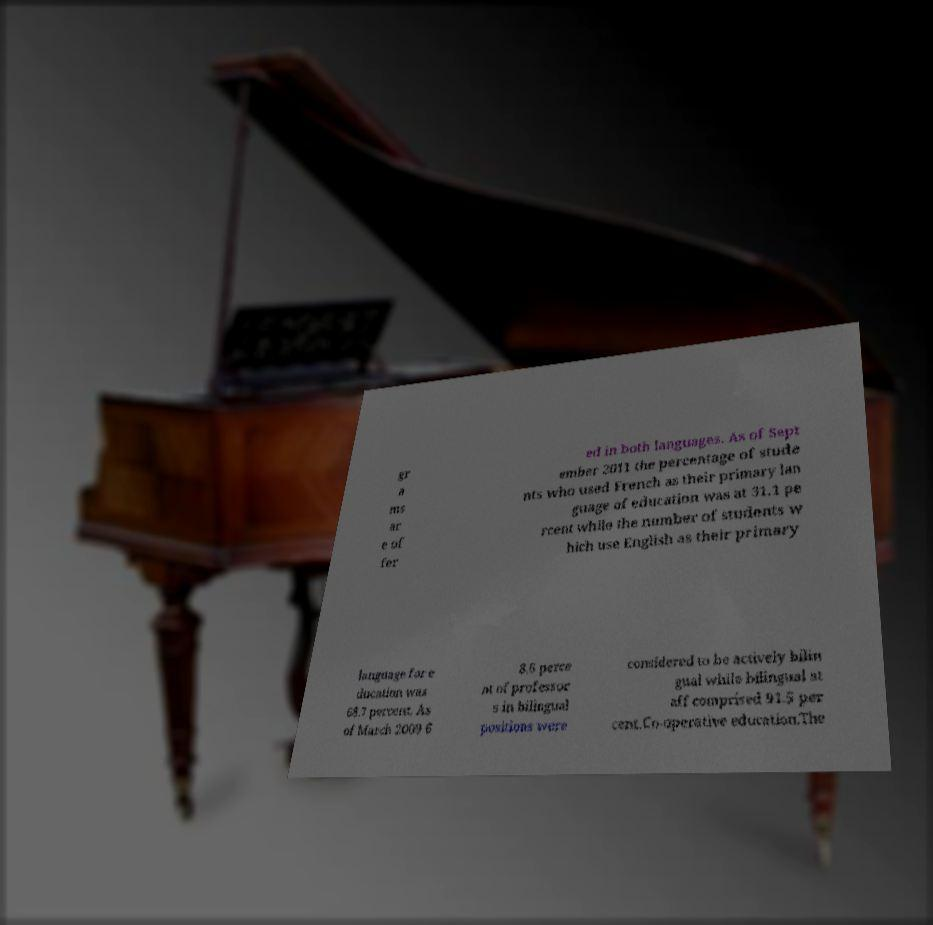For documentation purposes, I need the text within this image transcribed. Could you provide that? gr a ms ar e of fer ed in both languages. As of Sept ember 2011 the percentage of stude nts who used French as their primary lan guage of education was at 31.1 pe rcent while the number of students w hich use English as their primary language for e ducation was 68.7 percent. As of March 2009 6 8.6 perce nt of professor s in bilingual positions were considered to be actively bilin gual while bilingual st aff comprised 91.5 per cent.Co-operative education.The 